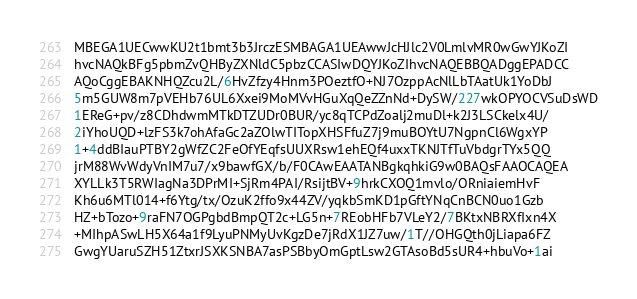<code> <loc_0><loc_0><loc_500><loc_500><_Python_>MBEGA1UECwwKU2t1bmt3b3JrczESMBAGA1UEAwwJcHJlc2V0LmlvMR0wGwYJKoZI
hvcNAQkBFg5pbmZvQHByZXNldC5pbzCCASIwDQYJKoZIhvcNAQEBBQADggEPADCC
AQoCggEBAKNHQZcu2L/6HvZfzy4Hnm3POeztfO+NJ7OzppAcNlLbTAatUk1YoDbJ
5m5GUW8m7pVEHb76UL6Xxei9MoMVvHGuXqQeZZnNd+DySW/227wkOPYOCVSuDsWD
1EReG+pv/z8CDhdwmMTkDTZUDr0BUR/yc8qTCPdZoalj2muDl+k2J3LSCkelx4U/
2iYhoUQD+lzFS3k7ohAfaGc2aZOlwTITopXHSFfuZ7j9muBOYtU7NgpnCl6WgxYP
1+4ddBIauPTBY2gWfZC2FeOfYEqfsUUXRsw1ehEQf4uxxTKNJTfTuVbdgrTYx5QQ
jrM88WvWdyVnIM7u7/x9bawfGX/b/F0CAwEAATANBgkqhkiG9w0BAQsFAAOCAQEA
XYLLk3T5RWIagNa3DPrMI+SjRm4PAI/RsijtBV+9hrkCXOQ1mvlo/ORniaiemHvF
Kh6u6MTl014+f6Ytg/tx/OzuK2ffo9x44ZV/yqkbSmKD1pGftYNqCnBCN0uo1Gzb
HZ+bTozo+9raFN7OGPgbdBmpQT2c+LG5n+7REobHFb7VLeY2/7BKtxNBRXfIxn4X
+MIhpASwLH5X64a1f9LyuPNMyUvKgzDe7jRdX1JZ7uw/1T//OHGQth0jLiapa6FZ
GwgYUaruSZH51ZtxrJSXKSNBA7asPSBbyOmGptLsw2GTAsoBd5sUR4+hbuVo+1ai</code> 